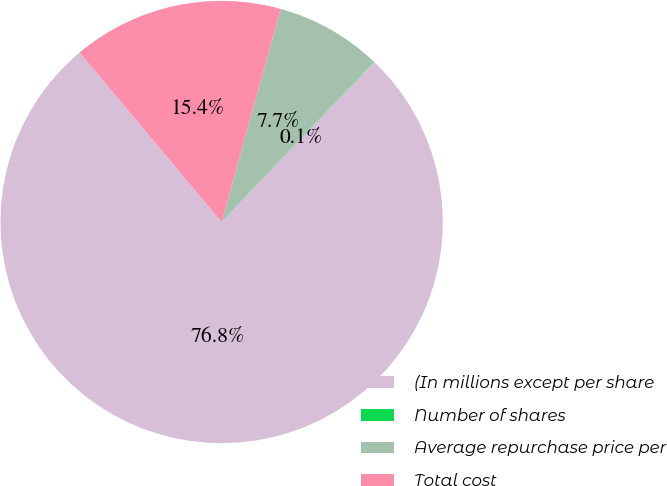Convert chart. <chart><loc_0><loc_0><loc_500><loc_500><pie_chart><fcel>(In millions except per share<fcel>Number of shares<fcel>Average repurchase price per<fcel>Total cost<nl><fcel>76.81%<fcel>0.05%<fcel>7.73%<fcel>15.41%<nl></chart> 